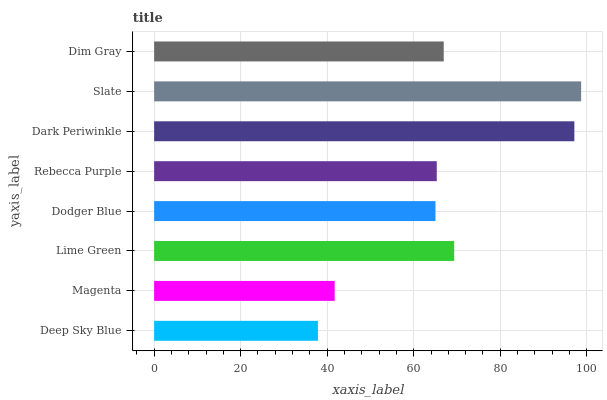Is Deep Sky Blue the minimum?
Answer yes or no. Yes. Is Slate the maximum?
Answer yes or no. Yes. Is Magenta the minimum?
Answer yes or no. No. Is Magenta the maximum?
Answer yes or no. No. Is Magenta greater than Deep Sky Blue?
Answer yes or no. Yes. Is Deep Sky Blue less than Magenta?
Answer yes or no. Yes. Is Deep Sky Blue greater than Magenta?
Answer yes or no. No. Is Magenta less than Deep Sky Blue?
Answer yes or no. No. Is Dim Gray the high median?
Answer yes or no. Yes. Is Rebecca Purple the low median?
Answer yes or no. Yes. Is Dark Periwinkle the high median?
Answer yes or no. No. Is Magenta the low median?
Answer yes or no. No. 